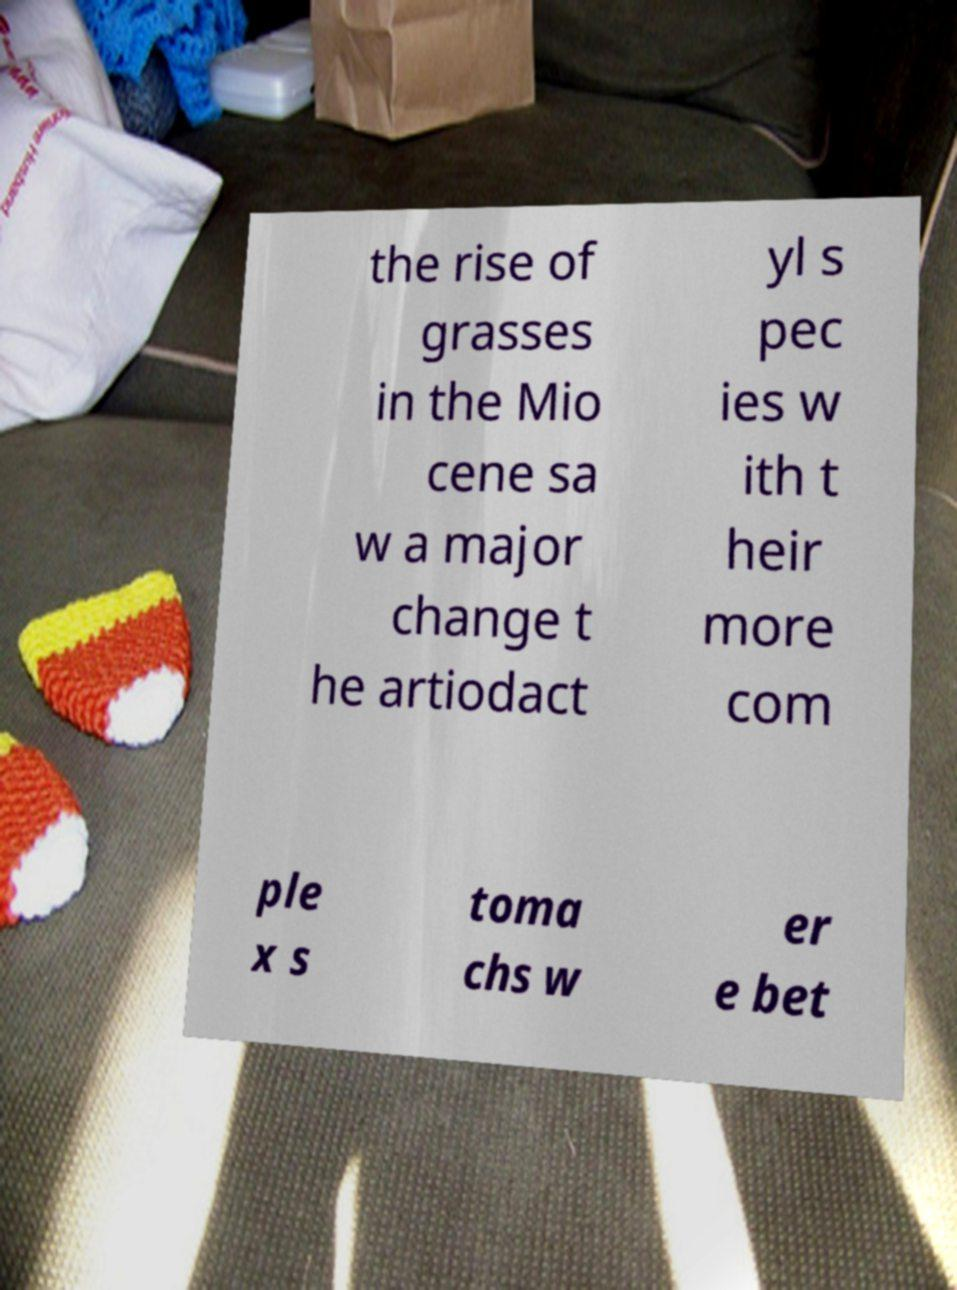Can you read and provide the text displayed in the image?This photo seems to have some interesting text. Can you extract and type it out for me? the rise of grasses in the Mio cene sa w a major change t he artiodact yl s pec ies w ith t heir more com ple x s toma chs w er e bet 